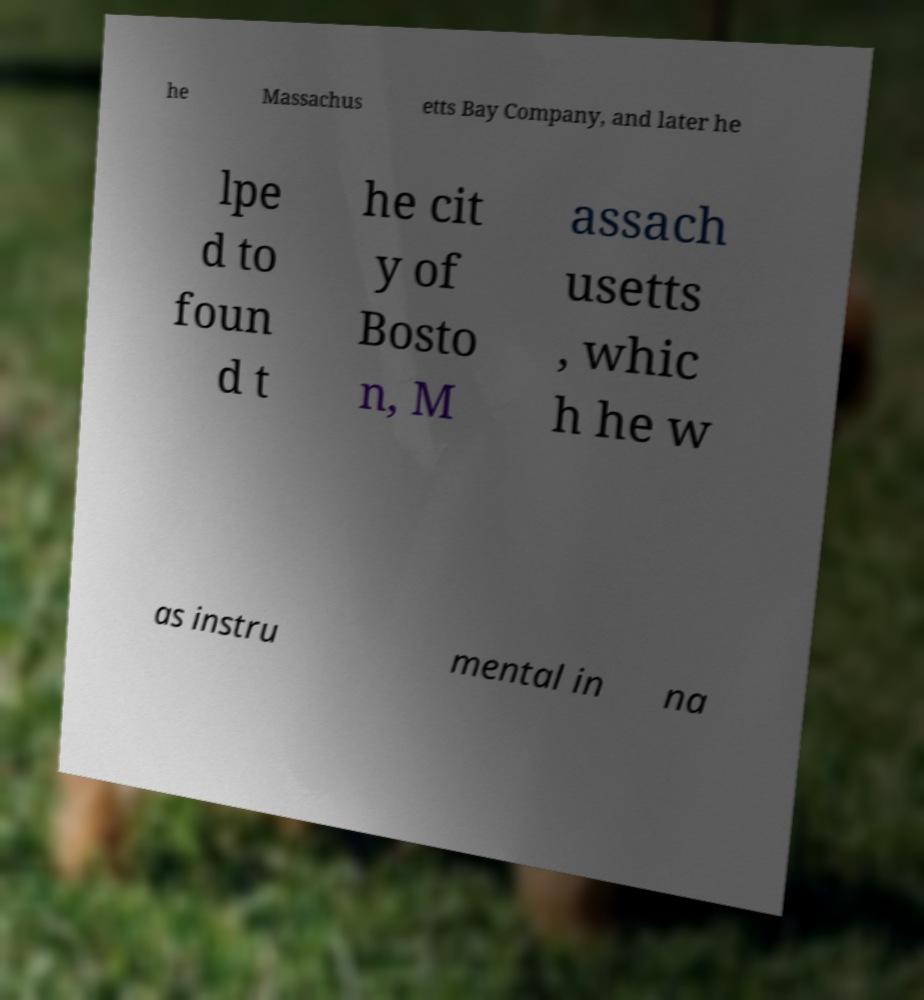For documentation purposes, I need the text within this image transcribed. Could you provide that? he Massachus etts Bay Company, and later he lpe d to foun d t he cit y of Bosto n, M assach usetts , whic h he w as instru mental in na 